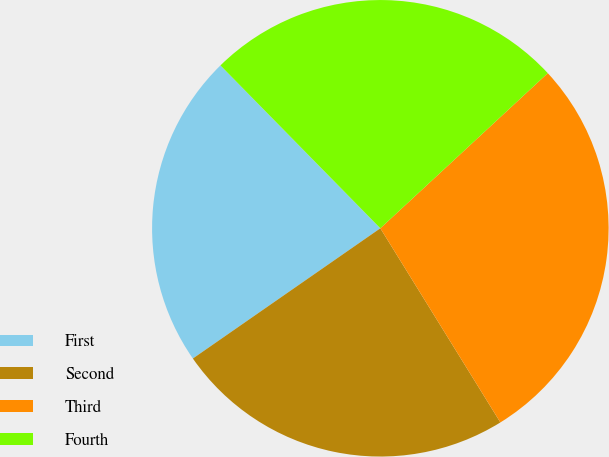Convert chart to OTSL. <chart><loc_0><loc_0><loc_500><loc_500><pie_chart><fcel>First<fcel>Second<fcel>Third<fcel>Fourth<nl><fcel>22.31%<fcel>24.15%<fcel>28.08%<fcel>25.46%<nl></chart> 